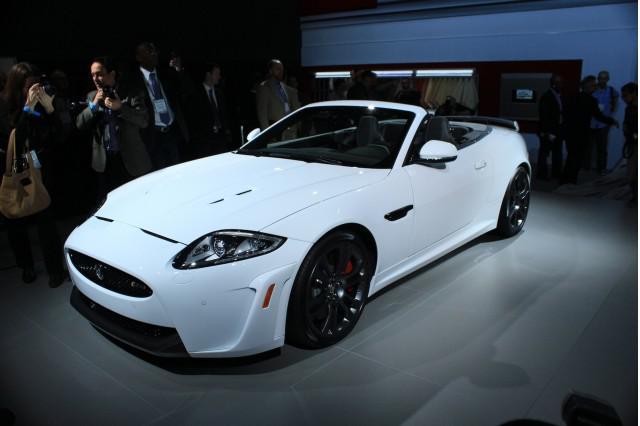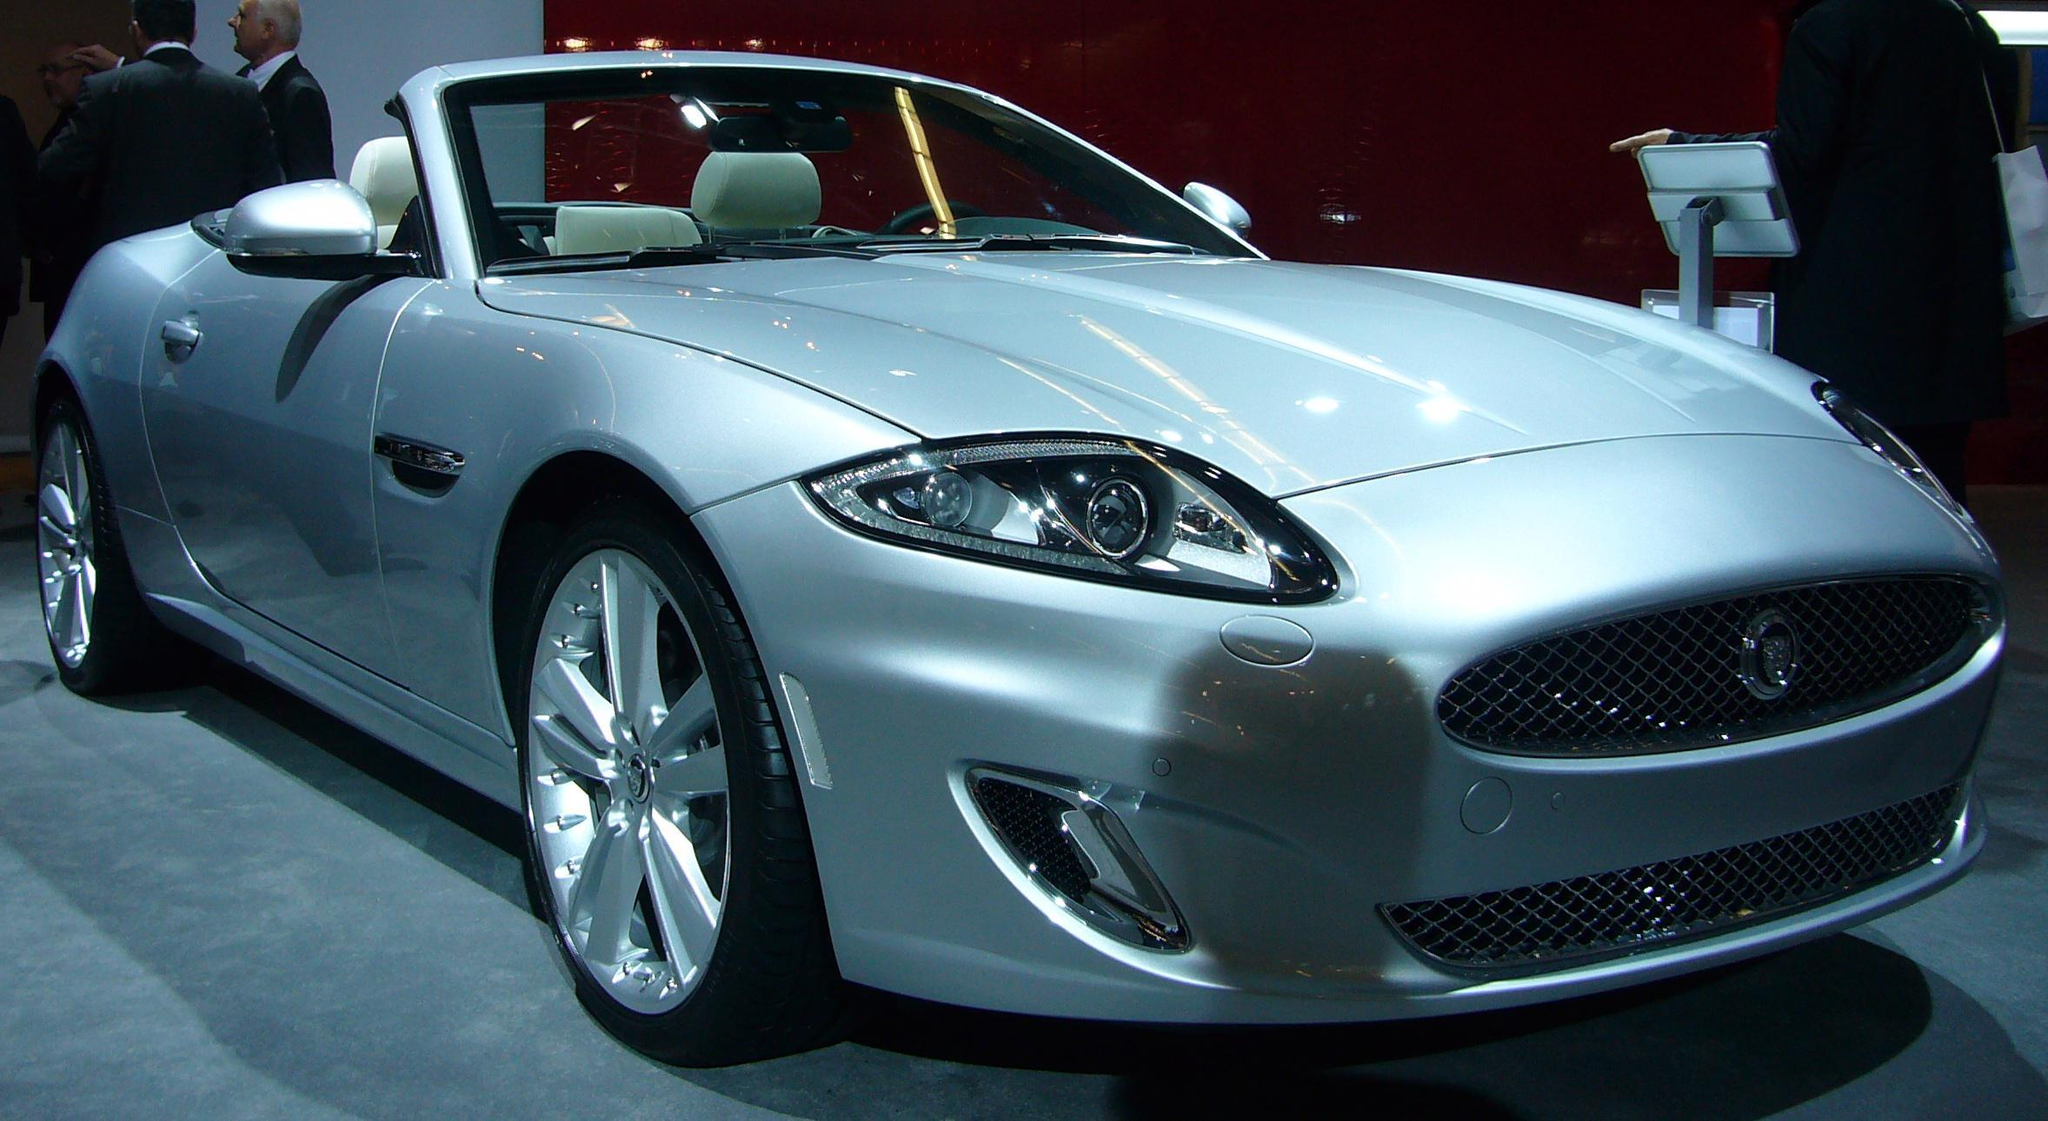The first image is the image on the left, the second image is the image on the right. Evaluate the accuracy of this statement regarding the images: "There is a black convertible on a paved street with its top down". Is it true? Answer yes or no. No. 